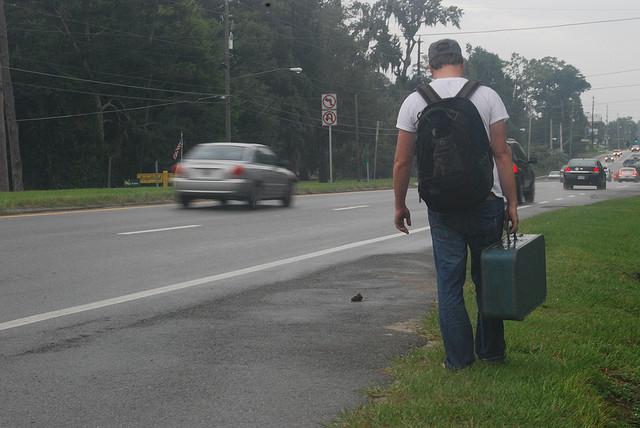What's on his back?
Answer briefly. Backpack. Is this man hitchhiking?
Quick response, please. No. What color is this person's shirt?
Be succinct. White. What is this person doing?
Give a very brief answer. Walking. Does this person have a tattoo?
Keep it brief. No. Is the vehicle a sedan or an SUV?
Write a very short answer. Sedan. Is it raining out?
Concise answer only. No. Is this a private car?
Short answer required. Yes. What color is the truck?
Give a very brief answer. Black. 